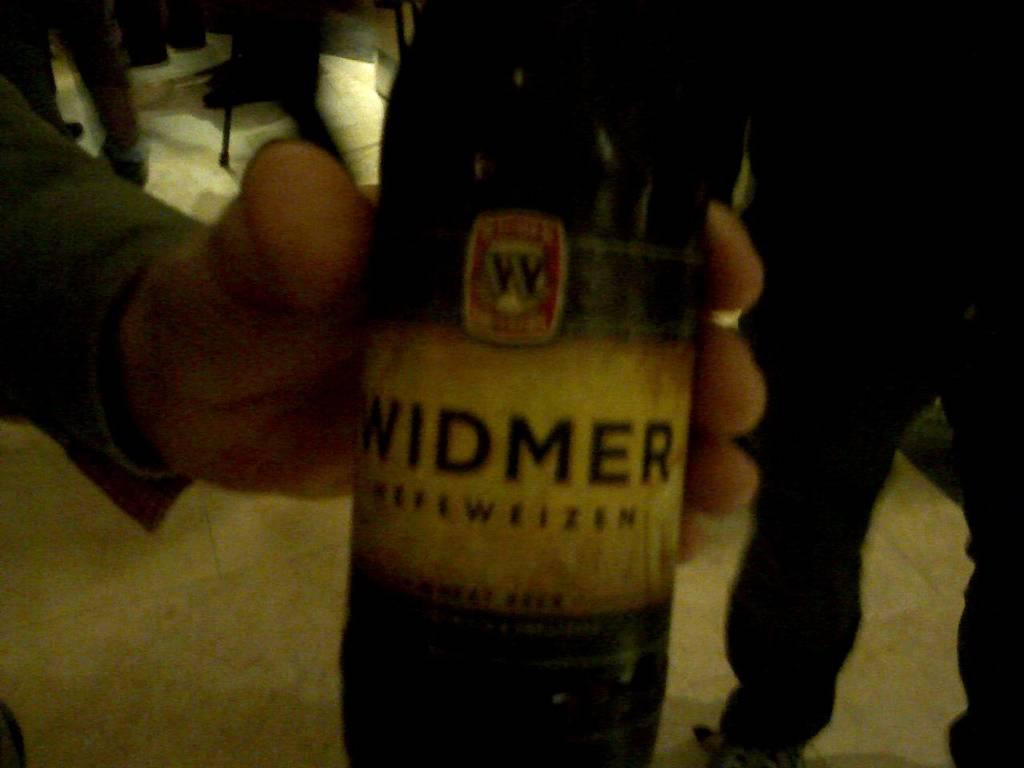What is the person's hand holding in the image? The person's hand is holding a bottle in the image. Where is the hand holding the bottle located in the image? The hand holding the bottle is in the center of the image. Can you describe the person on the right side of the image? Unfortunately, the provided facts do not give any information about the person on the right side of the image. What type of stitch is being used to sew the day on the person's father's shirt in the image? There is no information about a shirt, stitch, or father in the provided facts, and therefore no such activity can be observed in the image. 